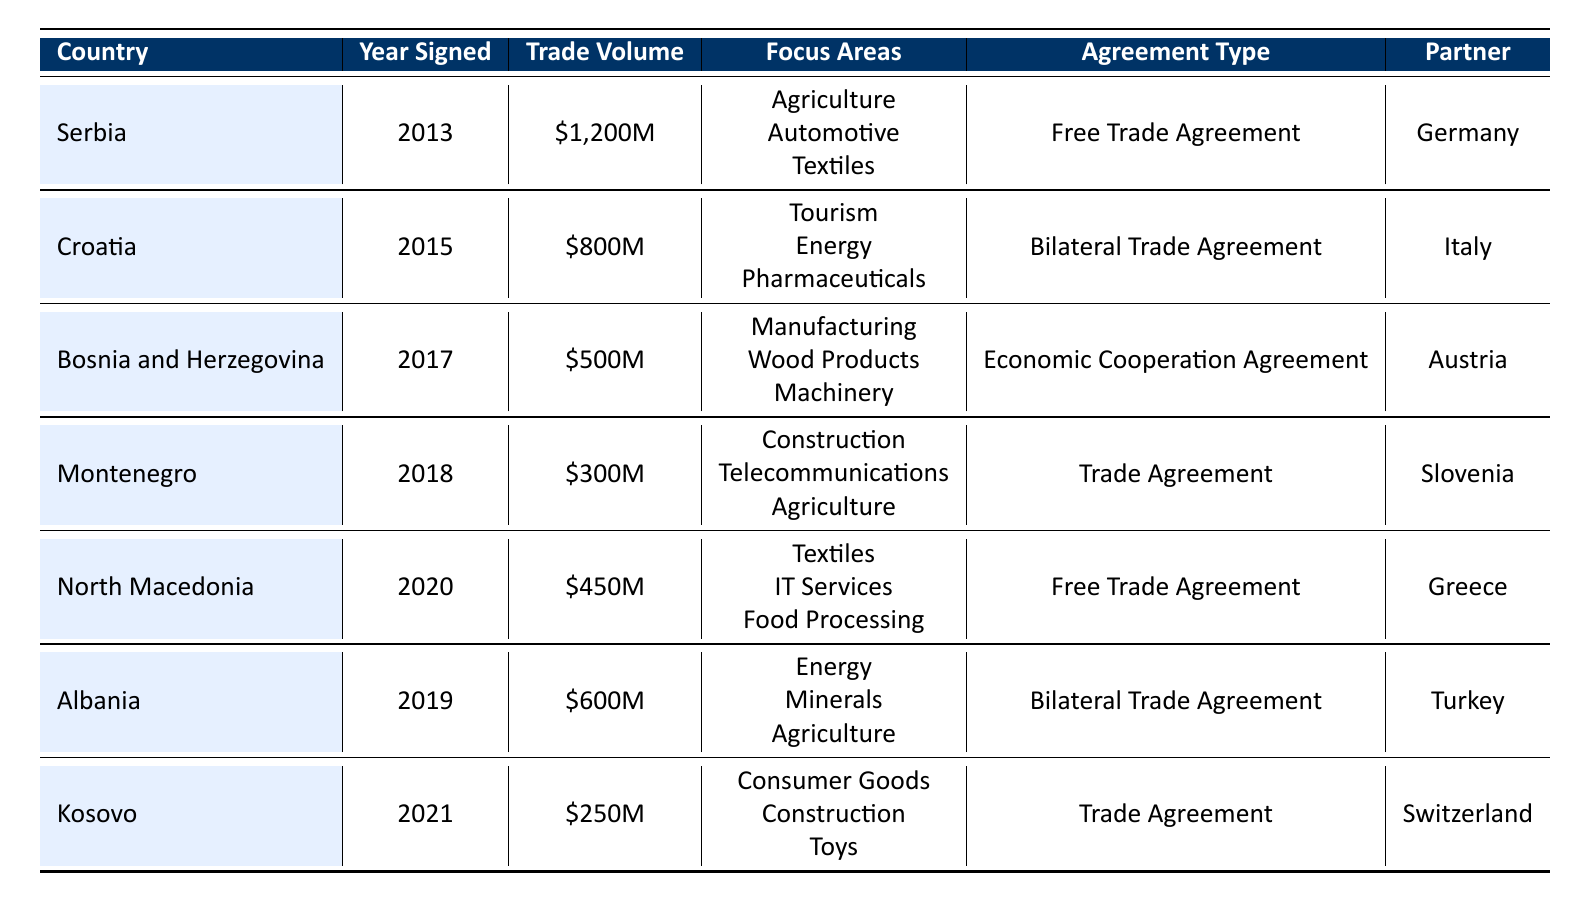What is the trade volume between Serbia and Germany? The table shows that the trade volume for the bilateral trade agreement between Serbia and Germany is \$1,200 million.
Answer: 1,200 million USD Which country signed an agreement in 2019? Referring to the table, Albania is the country that signed a bilateral trade agreement in 2019.
Answer: Albania How many trade agreements were signed after 2017? The agreements signed after 2017 are for Montenegro (2018), Albania (2019), North Macedonia (2020), and Kosovo (2021), making a total of 4 agreements.
Answer: 4 Which country has the lowest trade volume, and what is that volume? Looking at the table, Kosovo has the lowest trade volume at \$250 million among the listed countries.
Answer: 250 million USD Is there an Economic Cooperation Agreement with Bosnia and Herzegovina? Yes, the table indicates that Bosnia and Herzegovina has an Economic Cooperation Agreement signed in 2017.
Answer: Yes What is the average trade volume of the agreements signed in 2015 and 2019? The trade volumes for the agreements signed in these years are \$800 million (Croatia, 2015) and \$600 million (Albania, 2019). Summing these gives \$1,400 million. Dividing by 2 yields an average of \$700 million.
Answer: 700 million USD Which focus area is shared by both Serbia and Albania in their agreements? Both agreements include Agriculture as a common focus area. The table shows that Serbia's focus areas include Agriculture, and Albania's focus areas also include Agriculture.
Answer: Agriculture Count how many countries have free trade agreements in the table. The countries with free trade agreements are Serbia and North Macedonia. Thus, there are 2 countries with free trade agreements in the table.
Answer: 2 What is the year of the trade agreement between Montenegro and Slovenia? The table indicates that the trade agreement between Montenegro and Slovenia was signed in 2018.
Answer: 2018 Is tourism a focus area for the trade agreement with Croatia? Yes, tourism is listed as one of the focus areas for Croatia's bilateral trade agreement with Italy according to the table.
Answer: Yes 